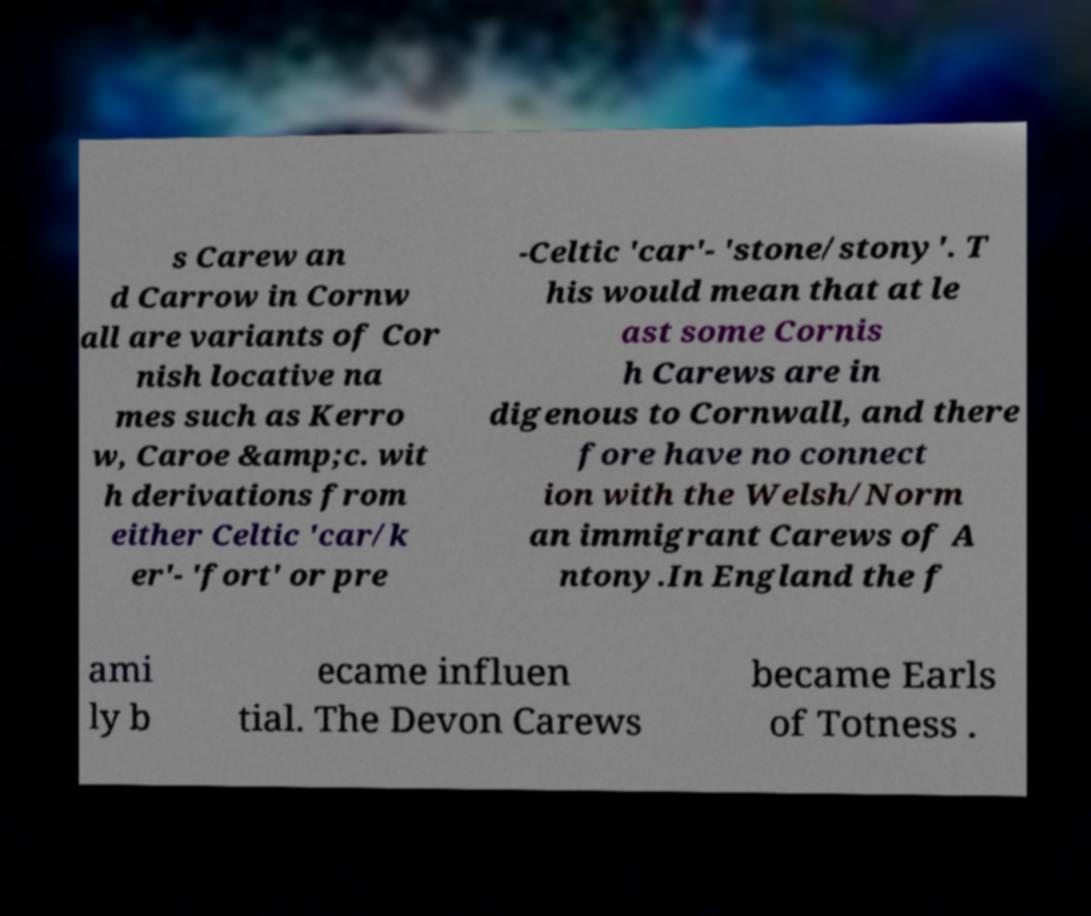Could you extract and type out the text from this image? s Carew an d Carrow in Cornw all are variants of Cor nish locative na mes such as Kerro w, Caroe &amp;c. wit h derivations from either Celtic 'car/k er'- 'fort' or pre -Celtic 'car'- 'stone/stony'. T his would mean that at le ast some Cornis h Carews are in digenous to Cornwall, and there fore have no connect ion with the Welsh/Norm an immigrant Carews of A ntony.In England the f ami ly b ecame influen tial. The Devon Carews became Earls of Totness . 